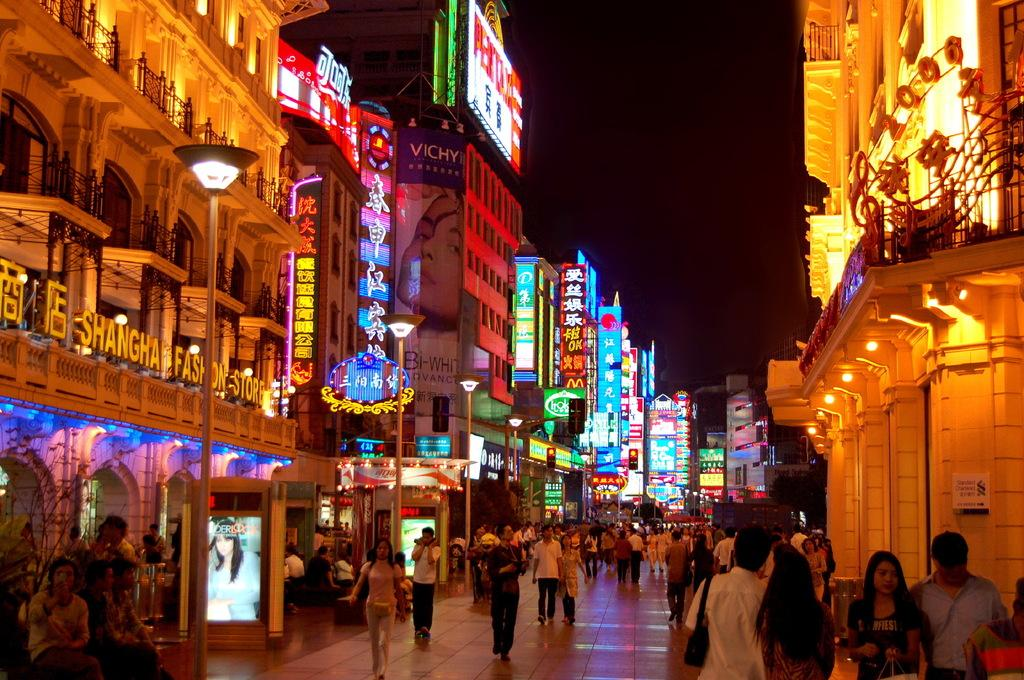<image>
Render a clear and concise summary of the photo. the outside of buildings with one of them labeled as 'shangha' 